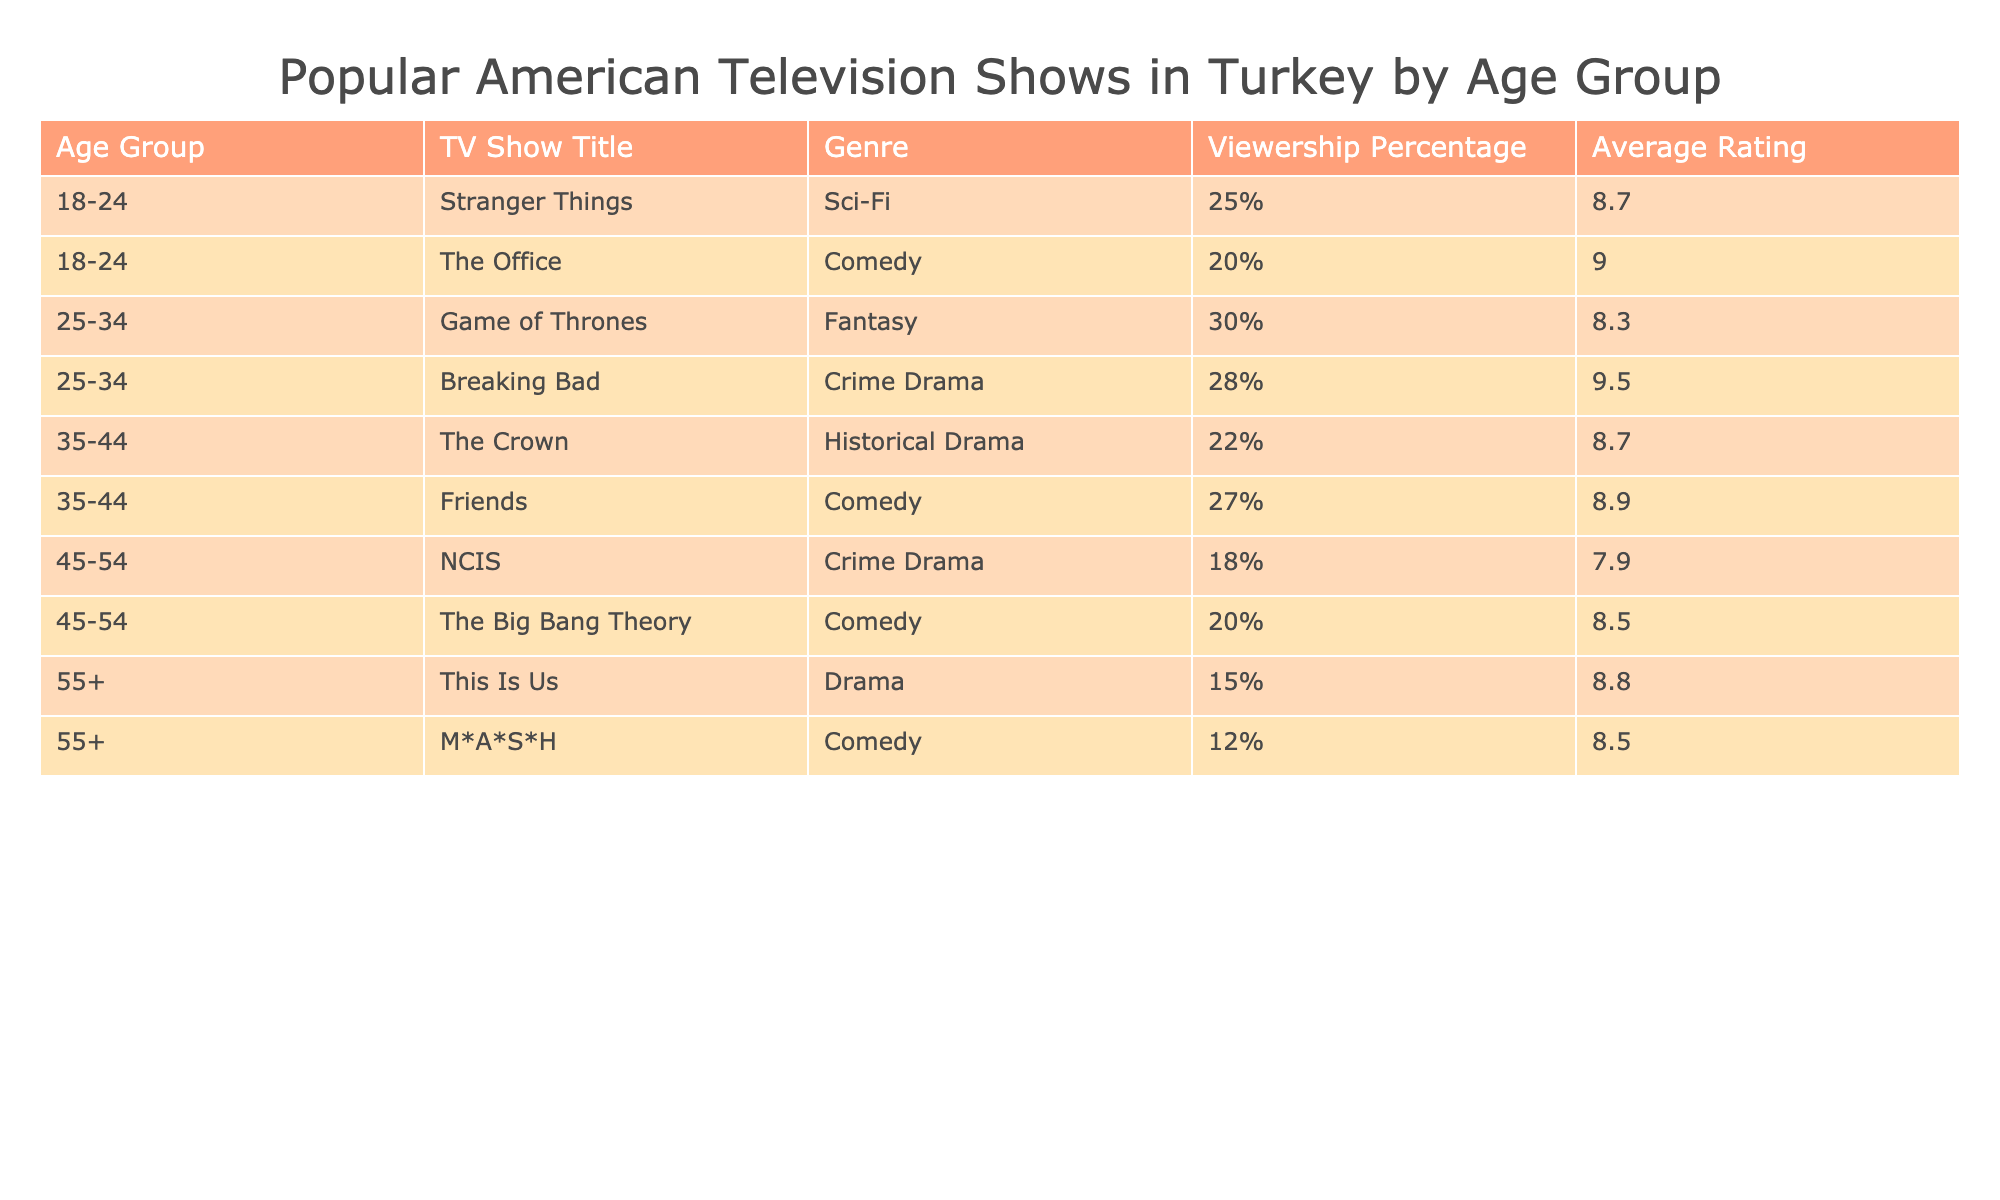What is the most popular TV show among the 25-34 age group? The table shows that "Game of Thrones" has the highest viewership percentage of 30% in the 25-34 age group.
Answer: Game of Thrones Which comedy show has the highest average rating in the table? "The Office" has the highest average rating of 9.0 among the comedy shows listed.
Answer: The Office How many total percentage points do the combined viewerships of the shows in the 35-44 age group represent? The viewership percentages for the shows in the 35-44 age group are 22% (The Crown) and 27% (Friends). Adding them gives 22 + 27 = 49%.
Answer: 49% Is "Breaking Bad" more popular than "Game of Thrones" among the 25-34 age group? "Breaking Bad" has a viewership percentage of 28%, which is less than "Game of Thrones," which has a viewership percentage of 30%. Therefore, "Breaking Bad" is not more popular.
Answer: No What is the average rating of the two comedy shows listed for the 45-54 age group? The average rating of the two shows, “NCIS” (7.9) and “The Big Bang Theory” (8.5), can be calculated as (7.9 + 8.5) / 2 = 8.2.
Answer: 8.2 What percentage of viewers aged 55+ watch "This Is Us"? The table indicates that "This Is Us" has a viewership percentage of 15% in the 55+ age group.
Answer: 15% Is "M*A*S*H" rated higher than "This Is Us"? "M*A*S*H" has an average rating of 8.5, while "This Is Us" has an average rating of 8.8, making "M*A*S*H" rated lower.
Answer: No Which age group has the lowest overall viewership for the shows listed? The 55+ age group has the lowest viewership percentages for both of its shows, at 15% and 12%, resulting in a lower overall viewership compared to other age groups.
Answer: 55+ age group 